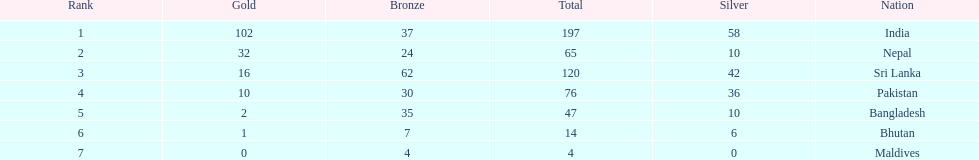What is the difference in total number of medals between india and nepal? 132. 